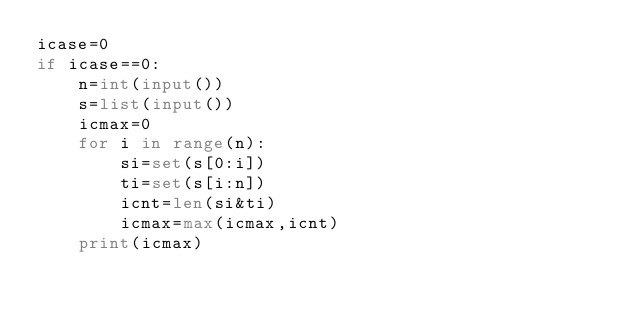Convert code to text. <code><loc_0><loc_0><loc_500><loc_500><_Python_>icase=0
if icase==0:
    n=int(input())
    s=list(input())
    icmax=0
    for i in range(n):
        si=set(s[0:i])
        ti=set(s[i:n])
        icnt=len(si&ti) 
        icmax=max(icmax,icnt)
    print(icmax)</code> 